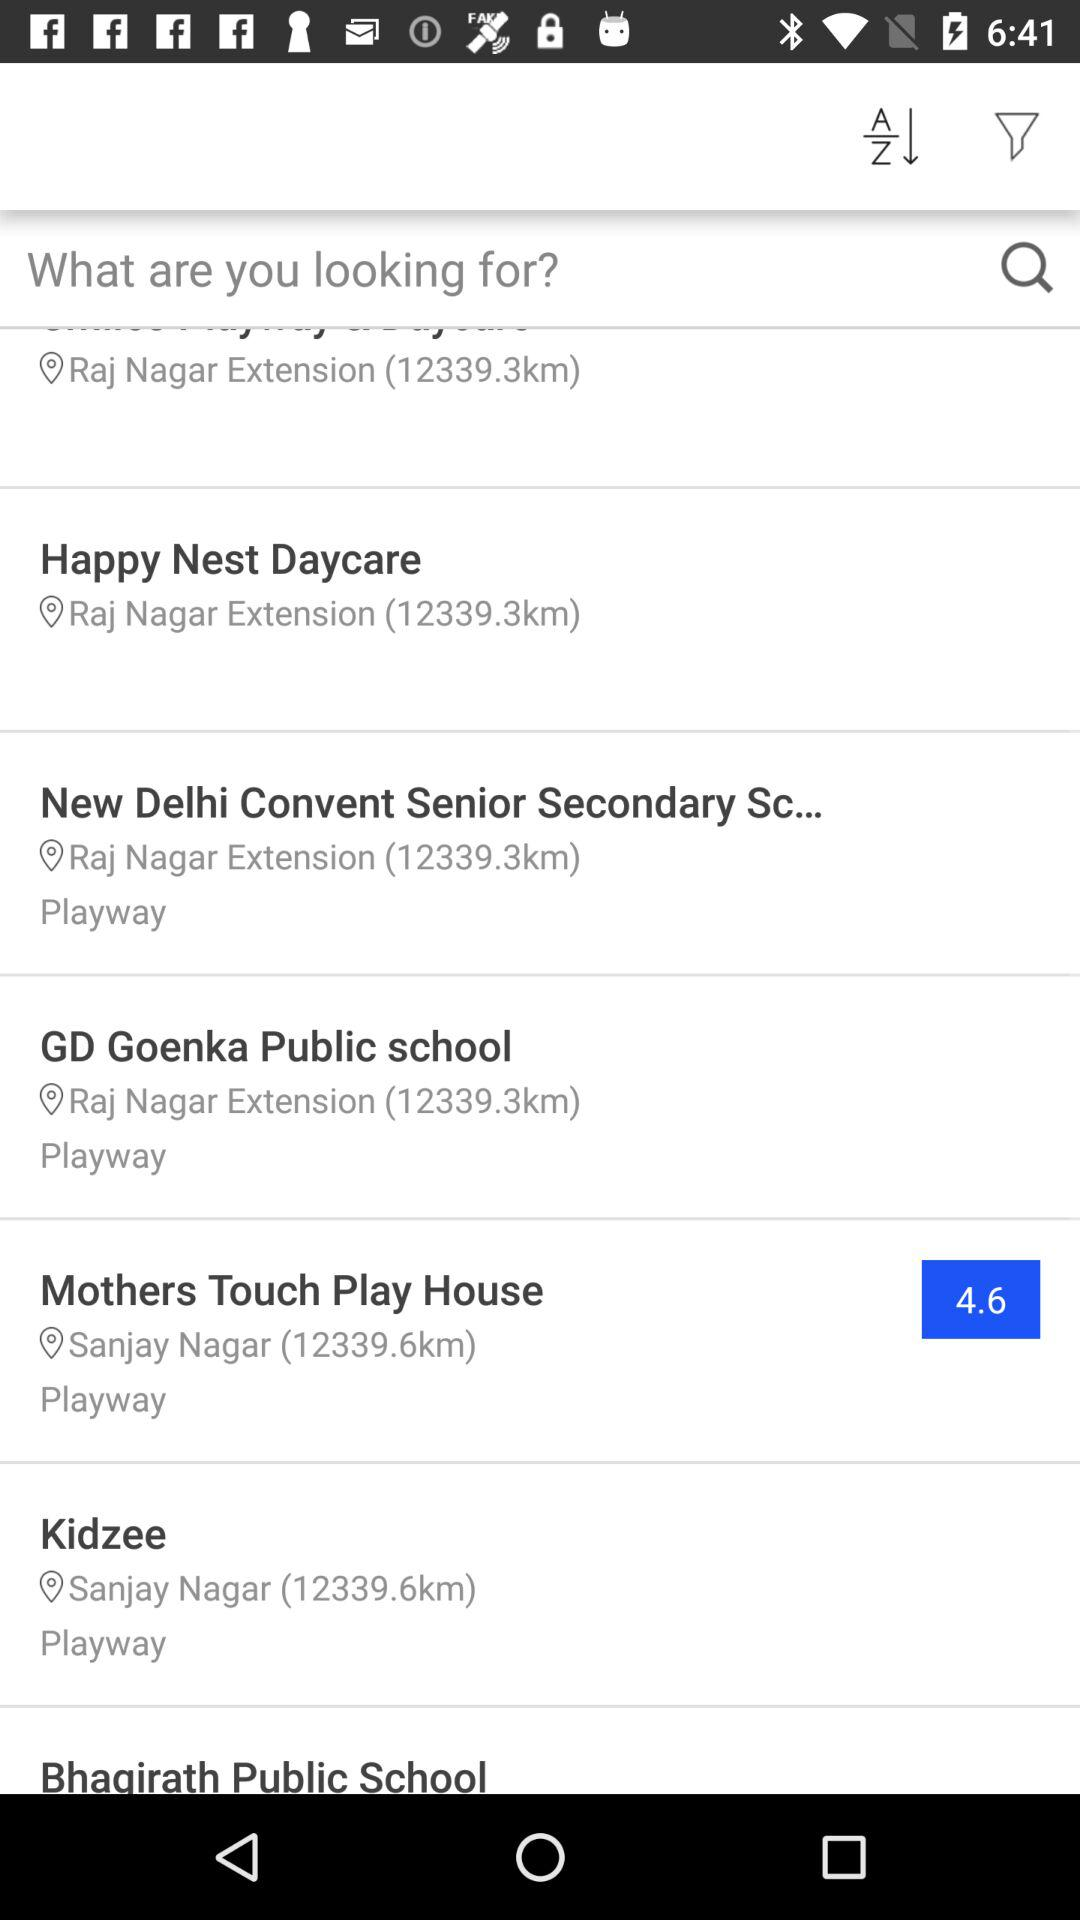What is the rating of Mothers Touch Play House? The rating is 4.6. 